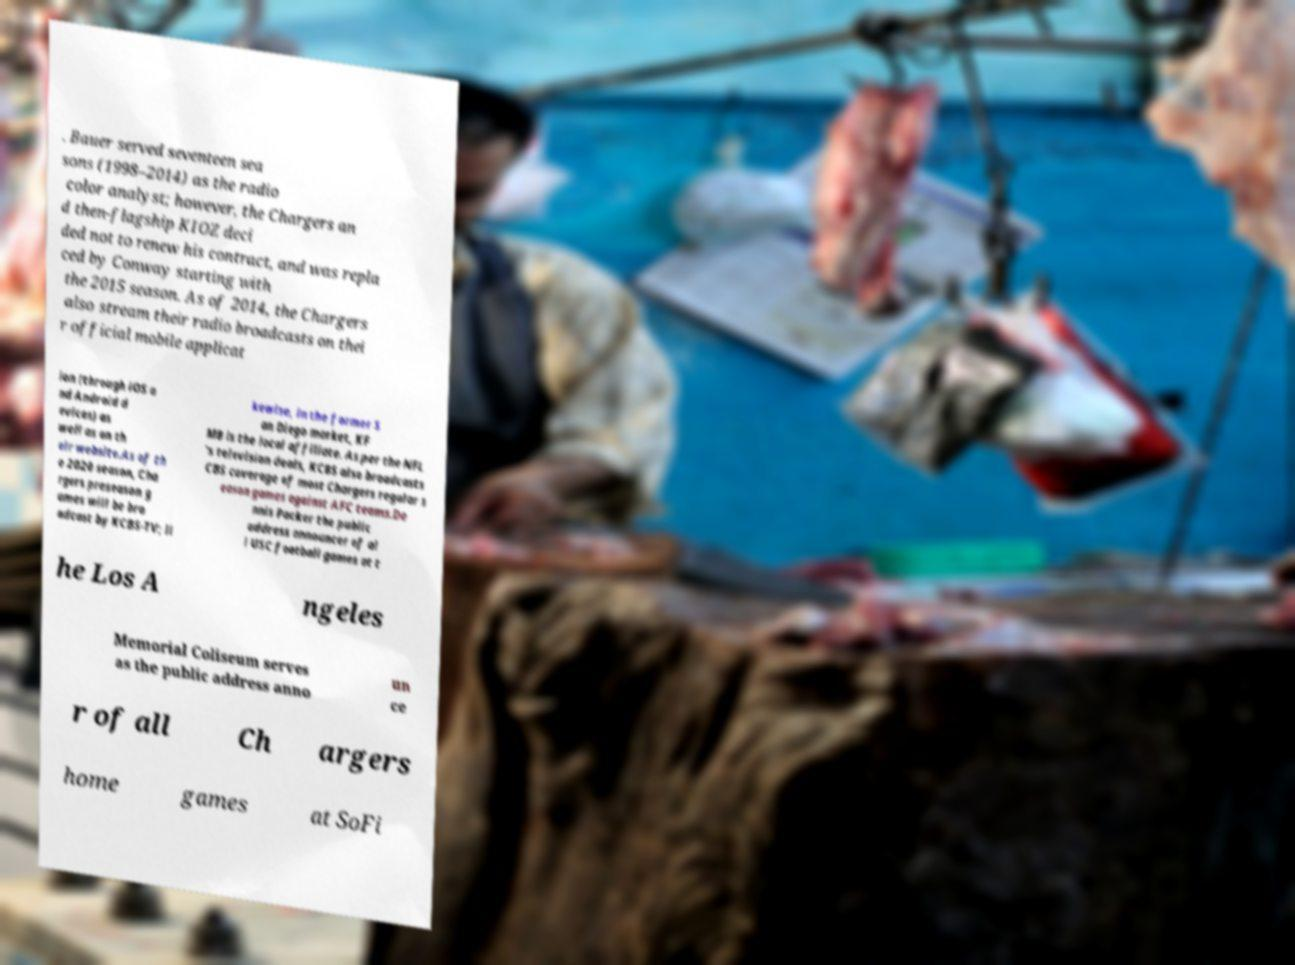I need the written content from this picture converted into text. Can you do that? . Bauer served seventeen sea sons (1998–2014) as the radio color analyst; however, the Chargers an d then-flagship KIOZ deci ded not to renew his contract, and was repla ced by Conway starting with the 2015 season. As of 2014, the Chargers also stream their radio broadcasts on thei r official mobile applicat ion (through iOS a nd Android d evices) as well as on th eir website.As of th e 2020 season, Cha rgers preseason g ames will be bro adcast by KCBS-TV; li kewise, in the former S an Diego market, KF MB is the local affiliate. As per the NFL 's television deals, KCBS also broadcasts CBS coverage of most Chargers regular s eason games against AFC teams.De nnis Packer the public address announcer of al l USC football games at t he Los A ngeles Memorial Coliseum serves as the public address anno un ce r of all Ch argers home games at SoFi 